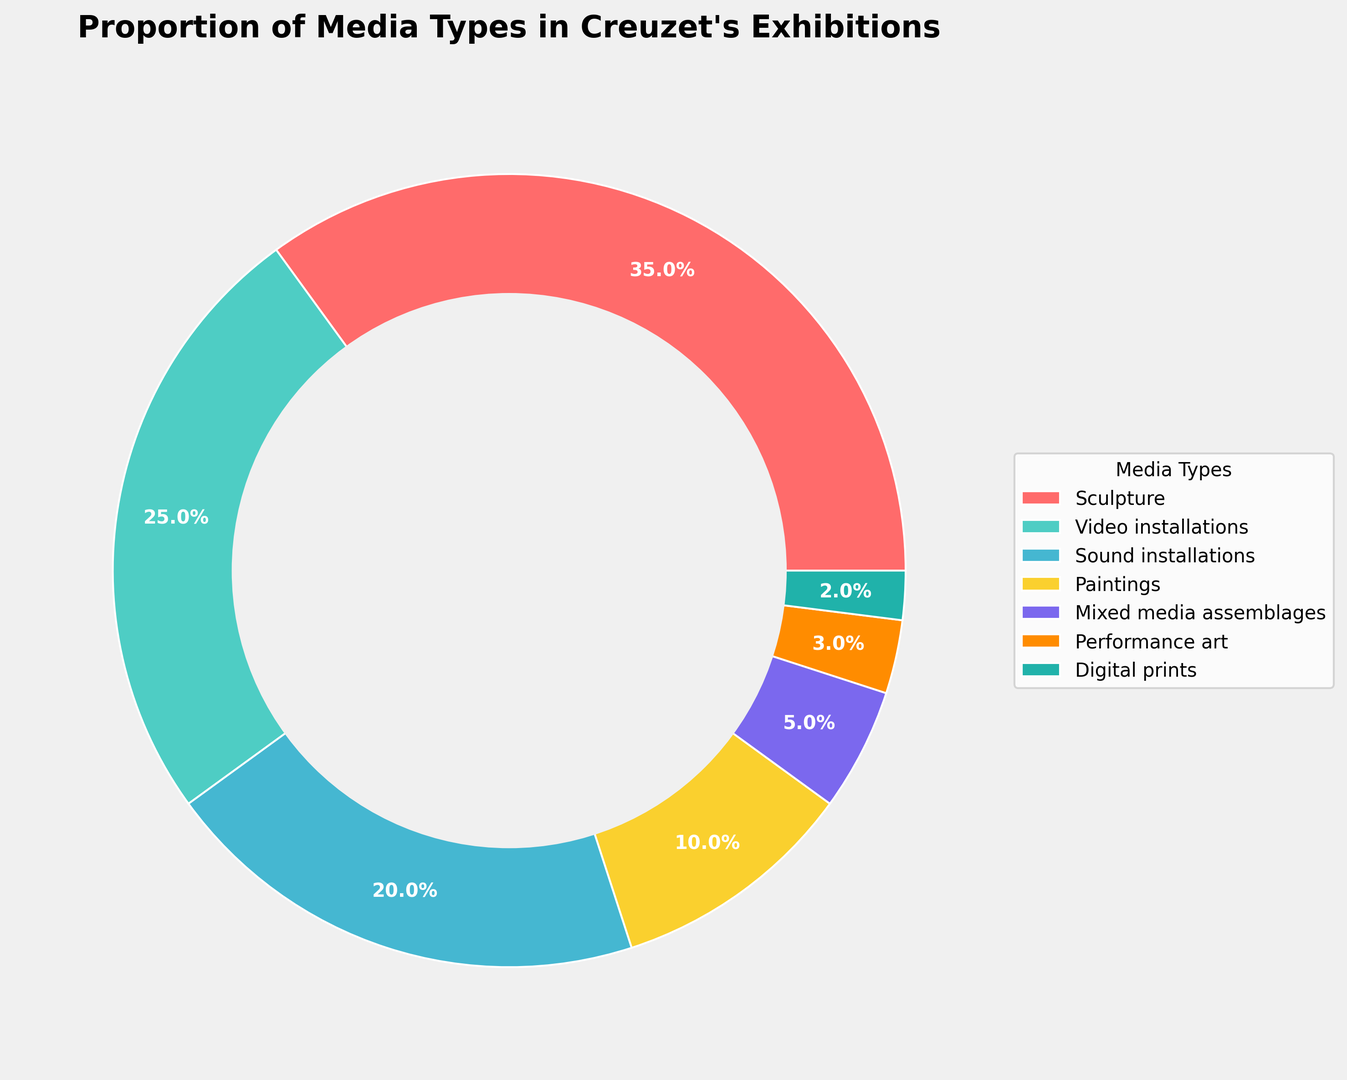Which media type is the most represented in Creuzet's exhibitions? The largest segment in the ring chart represents Sculpture.
Answer: Sculpture How much more prominent are Sculpture artworks compared to Performance art in Creuzet's exhibitions? Sculpture is represented by 35% and Performance art by 3%. The difference is 35% - 3% = 32%.
Answer: 32% What is the combined percentage of Video installations and Sound installations? Video installations make up 25% and Sound installations 20%. Adding these together gives 25% + 20% = 45%.
Answer: 45% Which media type is represented by the blue segment in the ring chart? By observing the color map from the chart, the blue segment corresponds to Video installations.
Answer: Video installations How does the representation of Mixed media assemblages compare to Digital prints? Mixed media assemblages constitute 5% whereas Digital prints are 2%. Mixed media assemblages are more than double that of Digital prints.
Answer: More than double Is the percentage of Paintings greater than the combined percentage of Performance art and Digital prints? Paintings are 10%, and the sum of Performance art (3%) and Digital prints (2%) is 5%. Since 10% is greater than 5%, Paintings have a larger representation.
Answer: Yes Which two media types have the smallest representation in Creuzet's exhibitions? Performance art and Digital prints have the smallest percentages, with 3% and 2%, respectively.
Answer: Performance art, Digital prints If we wanted to equally split the total percentage of Sound installations and Paintings among three new categories, what percentage would each new category have? Sound installations (20%) + Paintings (10%) = 30%. Dividing by 3 gives 30% / 3 = 10% per category.
Answer: 10% Place in order from highest to lowest the media types starting with the one that has the most significant representation. The order from highest to lowest is: Sculpture, Video installations, Sound installations, Paintings, Mixed media assemblages, Performance art, Digital prints.
Answer: Sculpture, Video installations, Sound installations, Paintings, Mixed media assemblages, Performance art, Digital prints What percentage of Creuzet's exhibitions is comprised of artworks other than Sculpture, Video installations, and Sound installations? The combined percentage of Sculpture, Video installations, and Sound installations is 35% + 25% + 20% = 80%. Therefore, the other media types comprise 100% - 80% = 20%.
Answer: 20% 